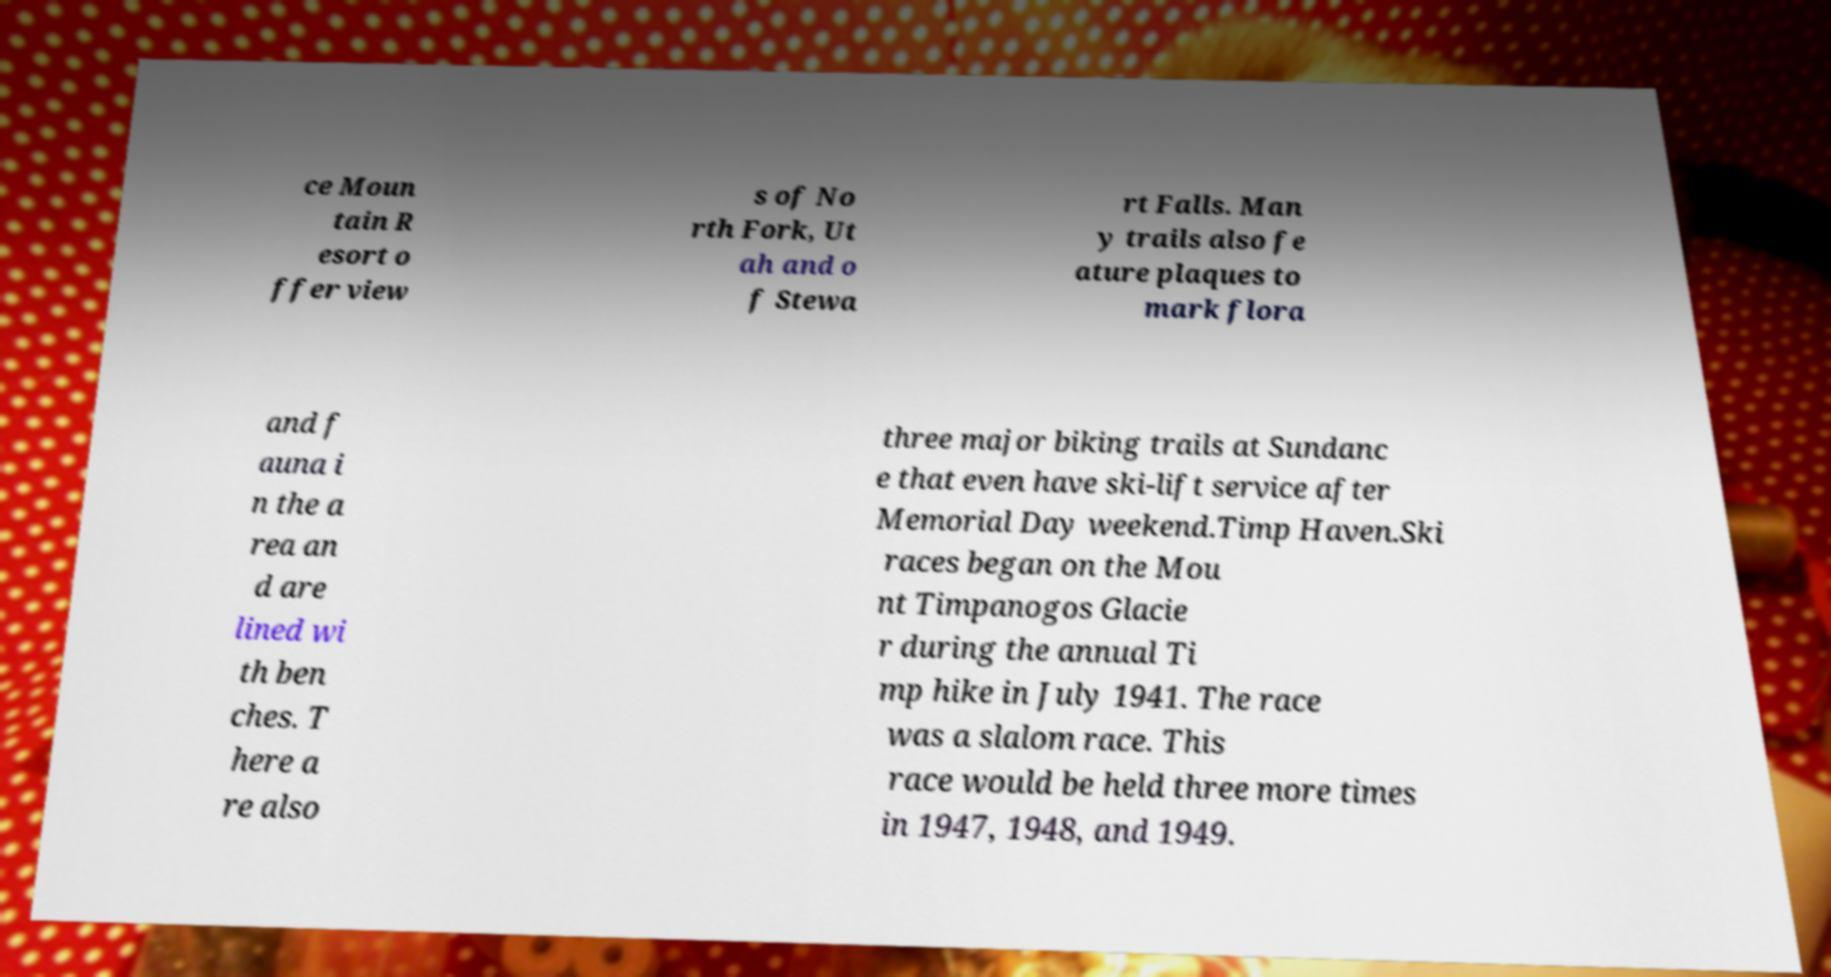There's text embedded in this image that I need extracted. Can you transcribe it verbatim? ce Moun tain R esort o ffer view s of No rth Fork, Ut ah and o f Stewa rt Falls. Man y trails also fe ature plaques to mark flora and f auna i n the a rea an d are lined wi th ben ches. T here a re also three major biking trails at Sundanc e that even have ski-lift service after Memorial Day weekend.Timp Haven.Ski races began on the Mou nt Timpanogos Glacie r during the annual Ti mp hike in July 1941. The race was a slalom race. This race would be held three more times in 1947, 1948, and 1949. 